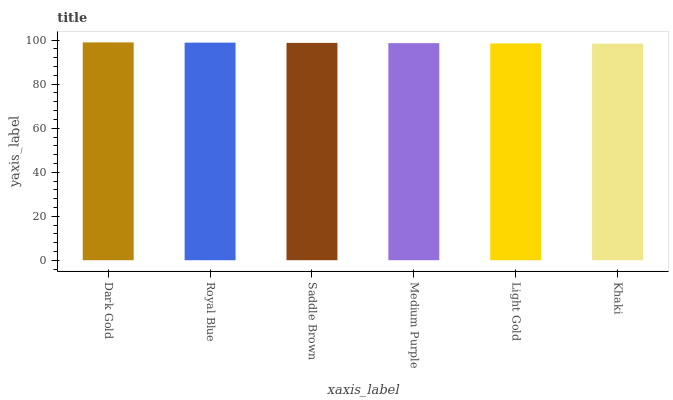Is Khaki the minimum?
Answer yes or no. Yes. Is Dark Gold the maximum?
Answer yes or no. Yes. Is Royal Blue the minimum?
Answer yes or no. No. Is Royal Blue the maximum?
Answer yes or no. No. Is Dark Gold greater than Royal Blue?
Answer yes or no. Yes. Is Royal Blue less than Dark Gold?
Answer yes or no. Yes. Is Royal Blue greater than Dark Gold?
Answer yes or no. No. Is Dark Gold less than Royal Blue?
Answer yes or no. No. Is Saddle Brown the high median?
Answer yes or no. Yes. Is Medium Purple the low median?
Answer yes or no. Yes. Is Khaki the high median?
Answer yes or no. No. Is Royal Blue the low median?
Answer yes or no. No. 